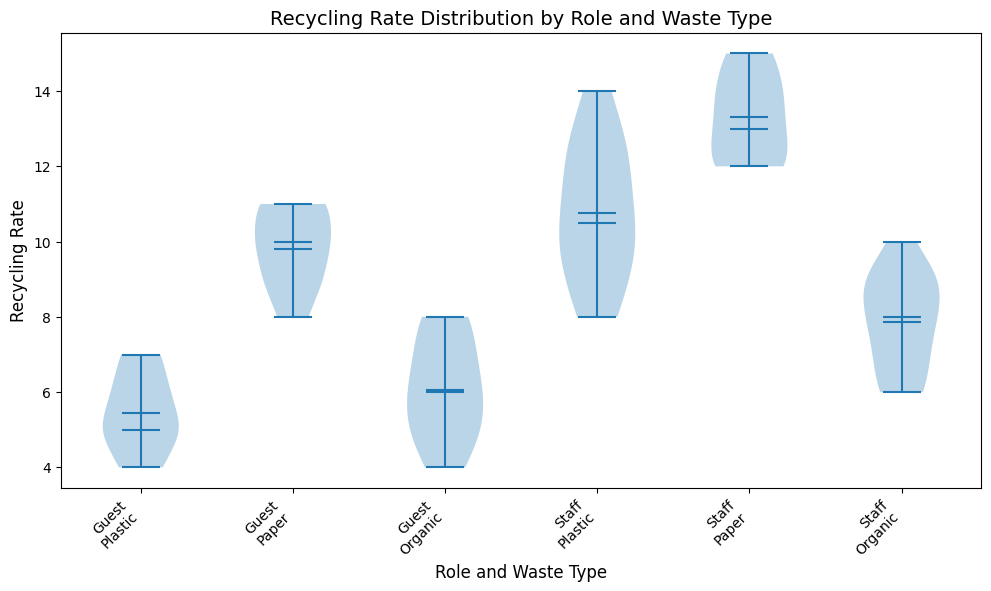Which role has a higher median recycling rate for plastic? Look for the median values represented by horizontal lines on the violin plots for plastic under both roles. Compare them; the role with a higher line has a higher median recycling rate.
Answer: Staff Between guests and staff, which group shows a greater spread in recycling rates for organic waste? Examine the width of the violin plots for organic waste. A wider plot indicates a greater spread. Compare the widths for guests and staff.
Answer: Guests Which waste type has the highest mean recycling rate for staff? Locate the markers for the mean values on the violin plots for each waste type under the staff category. Identify the waste type with the highest mean value.
Answer: Paper For guests, is the mean recycling rate for paper closer to their mean recycling rate for plastic or organic? Look at the markers for mean values on the violin plots for guests for plastic, paper, and organic. Compare the mean of paper with that of plastic and organic to see which is closer.
Answer: Organic What's the difference in median recycling rates between guests and staff for paper waste? Find the median values on the violin plots for paper waste for both guests and staff, and calculate the difference.
Answer: 3 Which role and waste type combination has the narrowest spread in recycling rates? Examine the width of all violin plots and identify the one with the narrowest spread, indicating the least variability.
Answer: Staff Organic Among the three waste types (plastic, paper, organic), which one shows the greatest difference in mean recycling rates between guests and staff? Compare the mean values for each waste type between guests and staff and identify the one with the largest differential.
Answer: Paper Is the recycling rate variability for plastic higher among guests or staff? Compare the width of the violin plots for plastic waste between guests and staff. Wider plots indicate higher variability.
Answer: Staff 